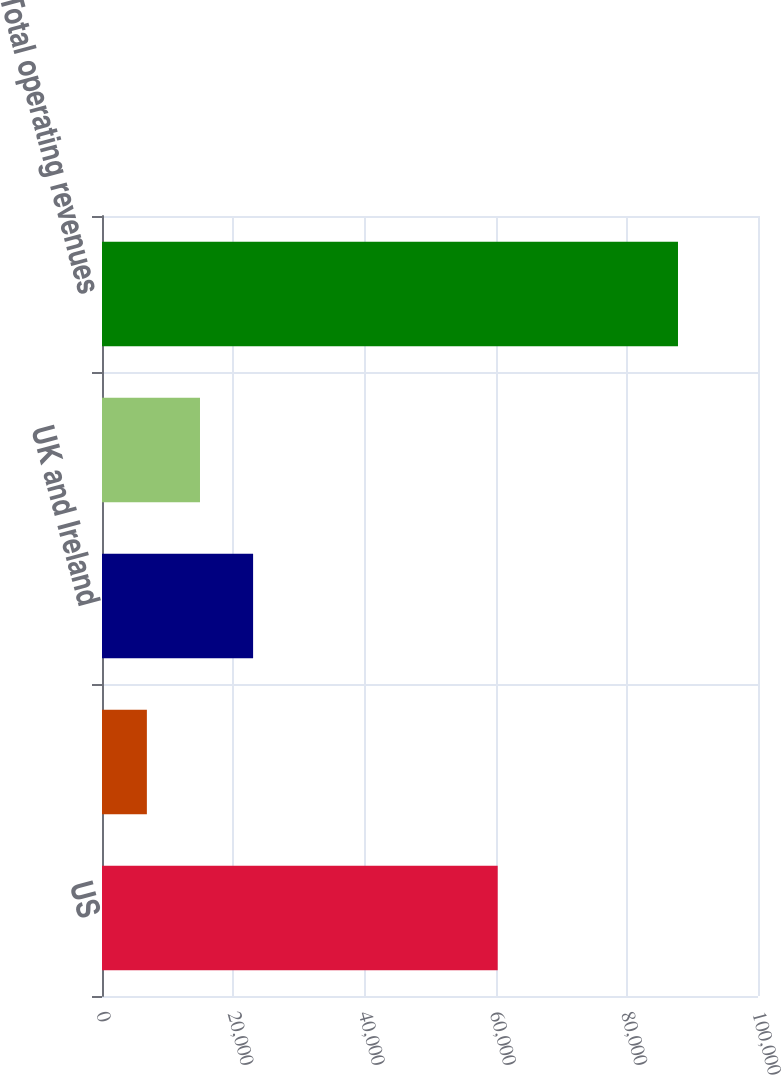Convert chart. <chart><loc_0><loc_0><loc_500><loc_500><bar_chart><fcel>US<fcel>Canada<fcel>UK and Ireland<fcel>Other countries<fcel>Total operating revenues<nl><fcel>60319<fcel>6841<fcel>23033.6<fcel>14937.3<fcel>87804<nl></chart> 